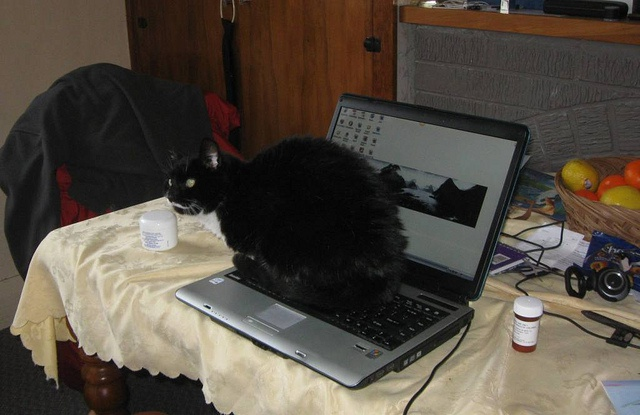Describe the objects in this image and their specific colors. I can see dining table in gray, darkgray, tan, and black tones, laptop in gray, black, darkgray, and lightgray tones, cat in gray, black, and darkgray tones, chair in gray, black, and maroon tones, and apple in gray, olive, and maroon tones in this image. 